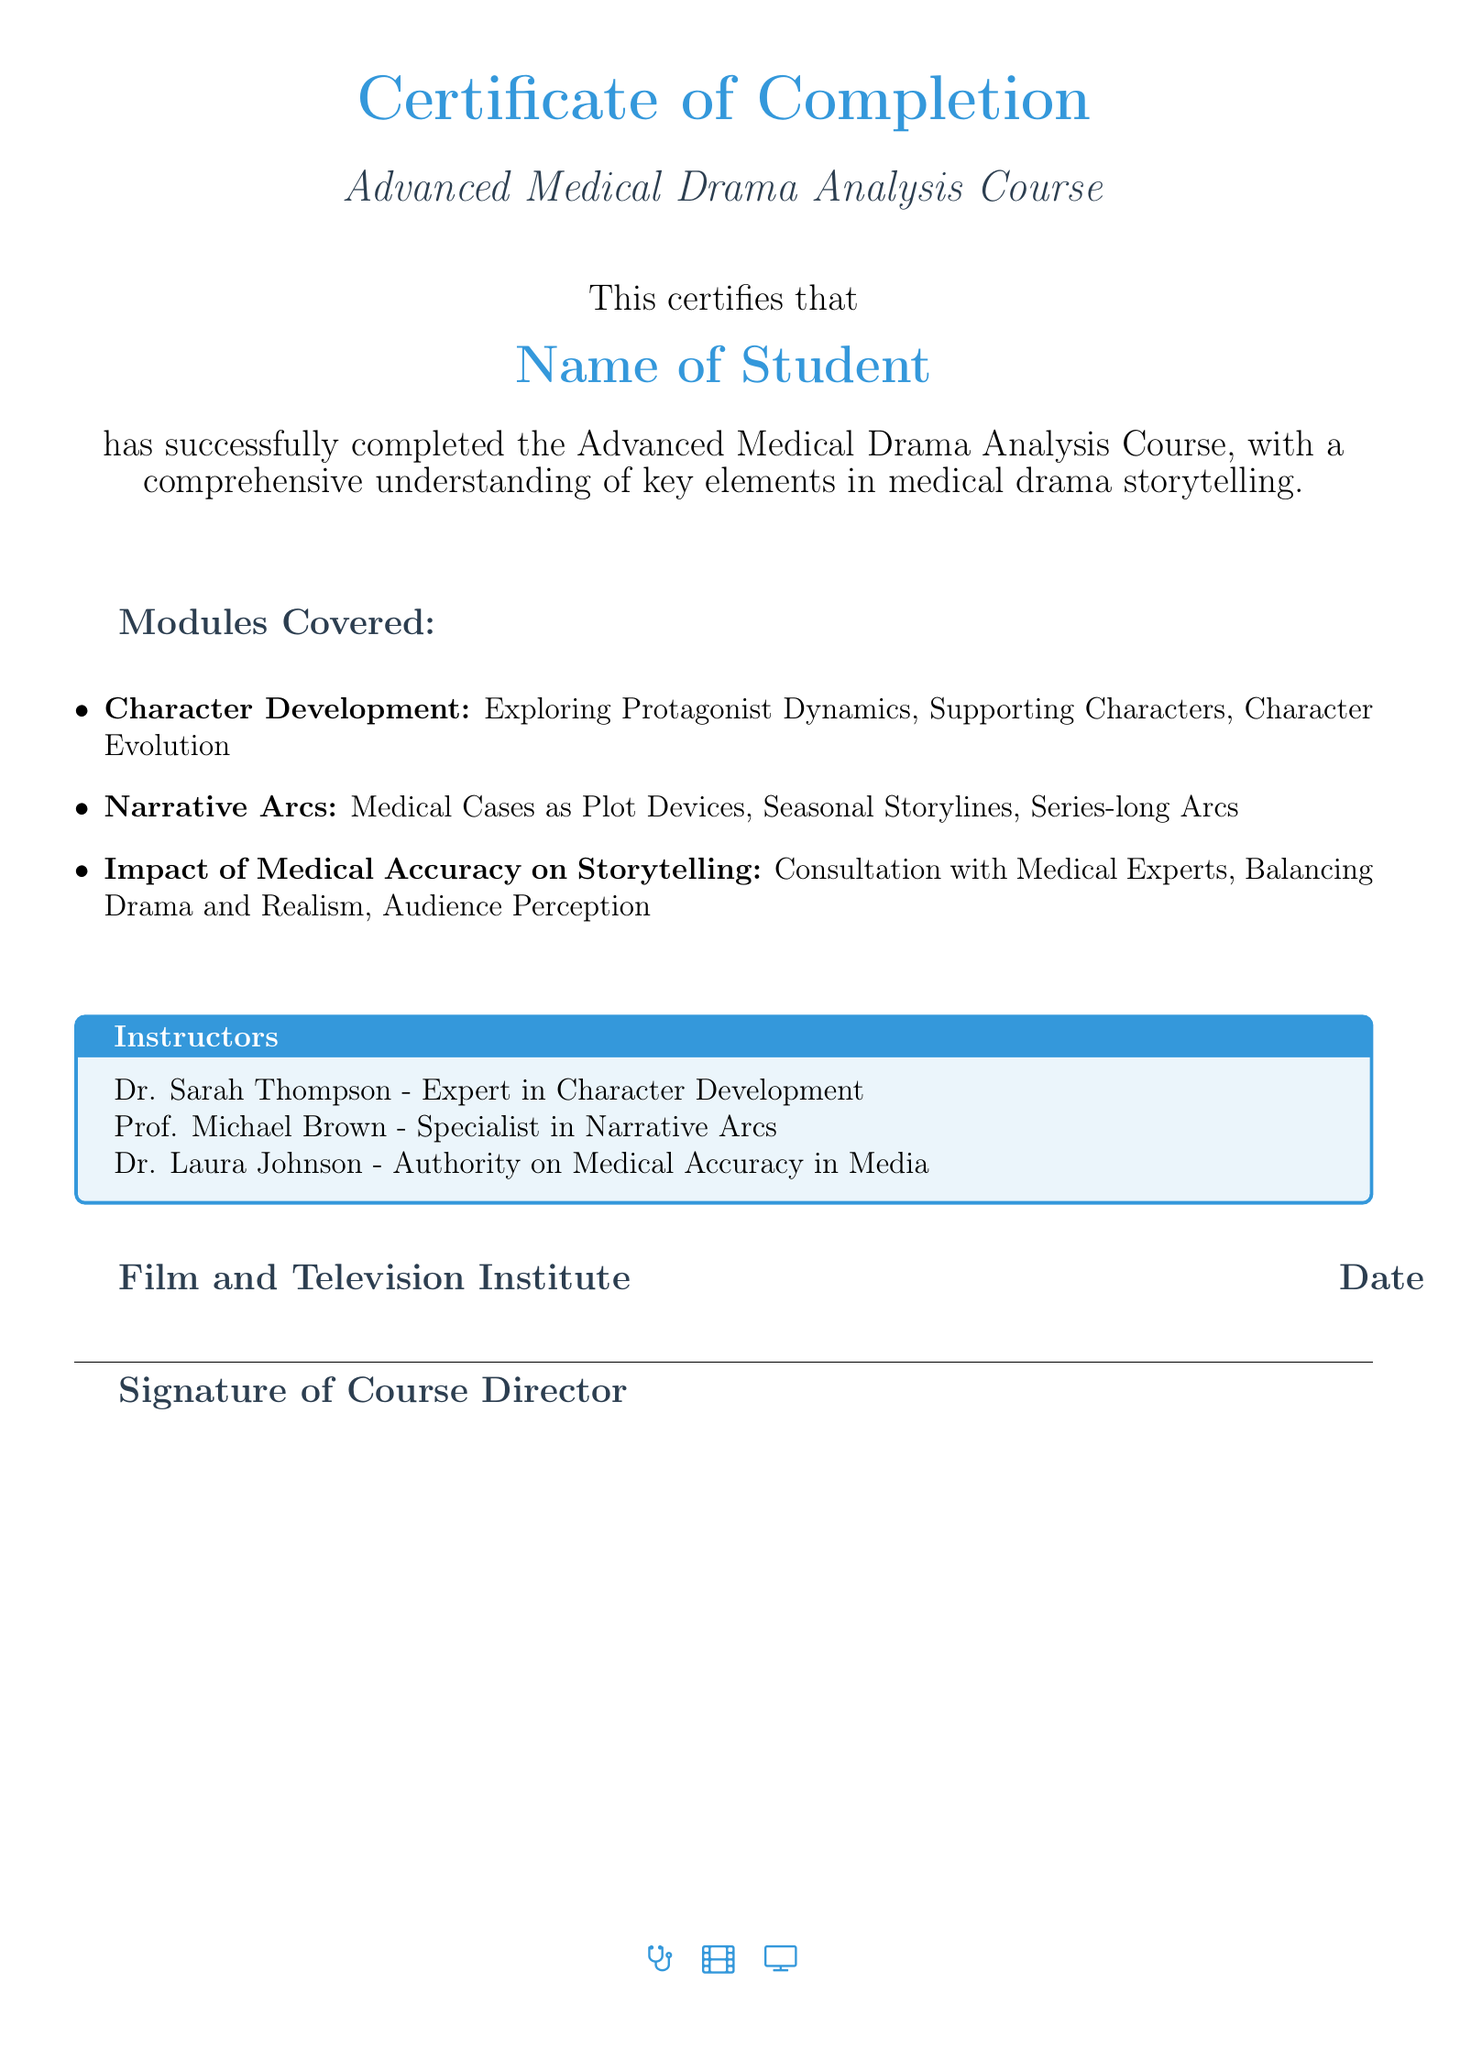what is the course title? The course title is mentioned in the document under the certificate section, which is "Advanced Medical Drama Analysis Course."
Answer: Advanced Medical Drama Analysis Course who is the student named in the certificate? The document provides a placeholder for the student's name, indicated as "Name of Student."
Answer: Name of Student which module focuses on character transformation? The module related to character transformation is specified under "Character Development."
Answer: Character Development who is an expert in character development? The document lists Dr. Sarah Thompson as the expert in character development.
Answer: Dr. Sarah Thompson what is the primary focus of the module on medical accuracy? The module on medical accuracy emphasizes the balance between drama and realism.
Answer: Balancing Drama and Realism when was the course completed? The document provides a placeholder for the completion date labeled as "Date."
Answer: Date what institution issued the certificate? The certificate mentions the issuing institution as "Film and Television Institute."
Answer: Film and Television Institute which module covers seasonal storylines? The module that includes seasonal storylines is under "Narrative Arcs."
Answer: Narrative Arcs who specializes in narrative arcs? The document states that Prof. Michael Brown specializes in narrative arcs.
Answer: Prof. Michael Brown 